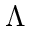<formula> <loc_0><loc_0><loc_500><loc_500>\Lambda</formula> 